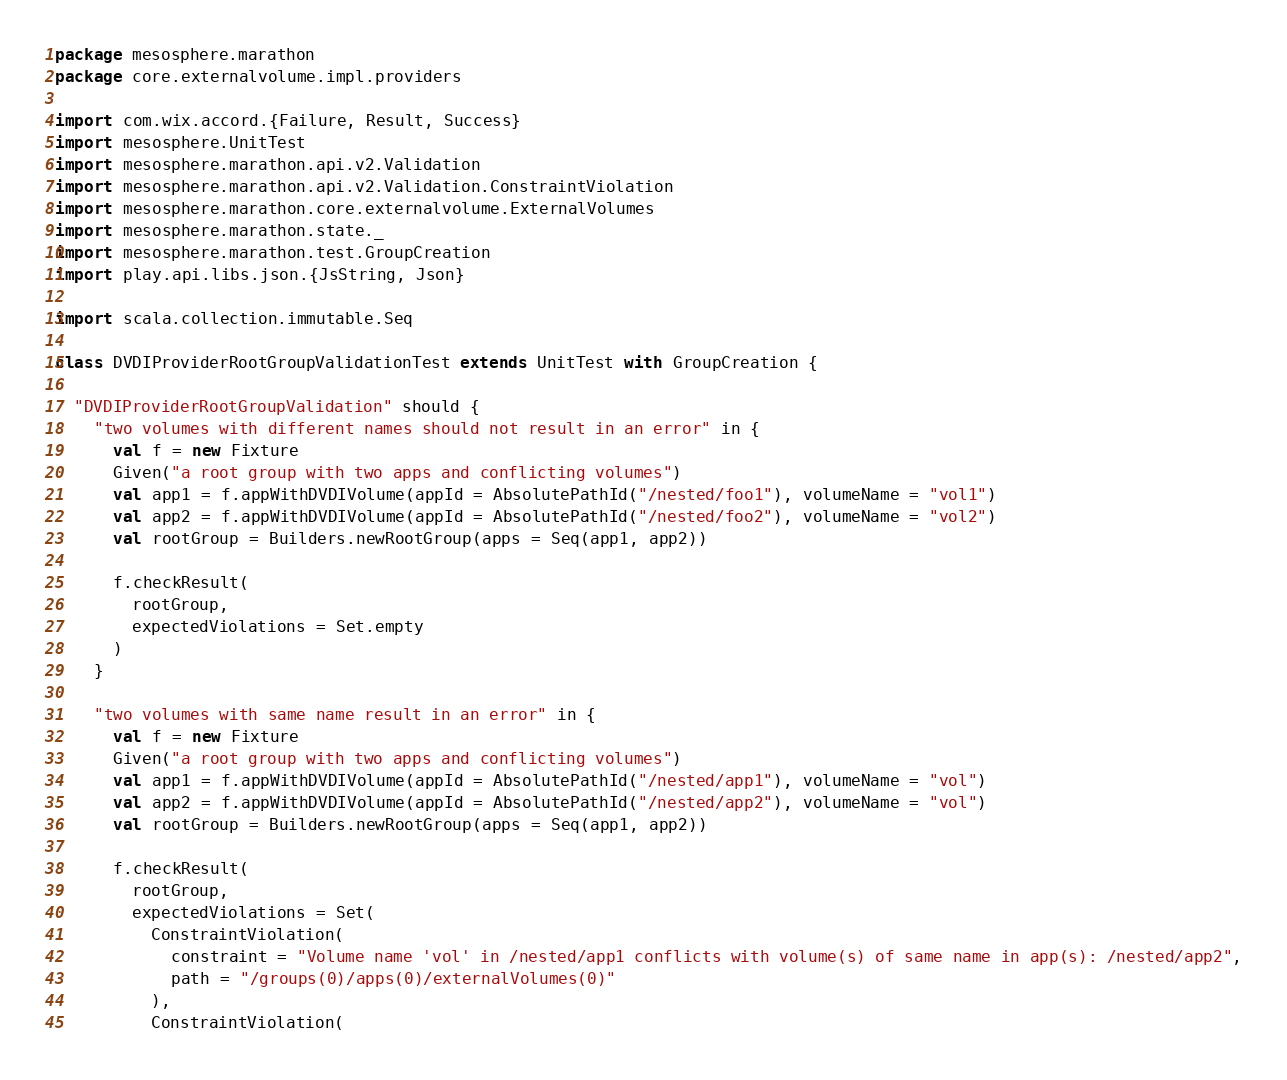Convert code to text. <code><loc_0><loc_0><loc_500><loc_500><_Scala_>package mesosphere.marathon
package core.externalvolume.impl.providers

import com.wix.accord.{Failure, Result, Success}
import mesosphere.UnitTest
import mesosphere.marathon.api.v2.Validation
import mesosphere.marathon.api.v2.Validation.ConstraintViolation
import mesosphere.marathon.core.externalvolume.ExternalVolumes
import mesosphere.marathon.state._
import mesosphere.marathon.test.GroupCreation
import play.api.libs.json.{JsString, Json}

import scala.collection.immutable.Seq

class DVDIProviderRootGroupValidationTest extends UnitTest with GroupCreation {

  "DVDIProviderRootGroupValidation" should {
    "two volumes with different names should not result in an error" in {
      val f = new Fixture
      Given("a root group with two apps and conflicting volumes")
      val app1 = f.appWithDVDIVolume(appId = AbsolutePathId("/nested/foo1"), volumeName = "vol1")
      val app2 = f.appWithDVDIVolume(appId = AbsolutePathId("/nested/foo2"), volumeName = "vol2")
      val rootGroup = Builders.newRootGroup(apps = Seq(app1, app2))

      f.checkResult(
        rootGroup,
        expectedViolations = Set.empty
      )
    }

    "two volumes with same name result in an error" in {
      val f = new Fixture
      Given("a root group with two apps and conflicting volumes")
      val app1 = f.appWithDVDIVolume(appId = AbsolutePathId("/nested/app1"), volumeName = "vol")
      val app2 = f.appWithDVDIVolume(appId = AbsolutePathId("/nested/app2"), volumeName = "vol")
      val rootGroup = Builders.newRootGroup(apps = Seq(app1, app2))

      f.checkResult(
        rootGroup,
        expectedViolations = Set(
          ConstraintViolation(
            constraint = "Volume name 'vol' in /nested/app1 conflicts with volume(s) of same name in app(s): /nested/app2",
            path = "/groups(0)/apps(0)/externalVolumes(0)"
          ),
          ConstraintViolation(</code> 